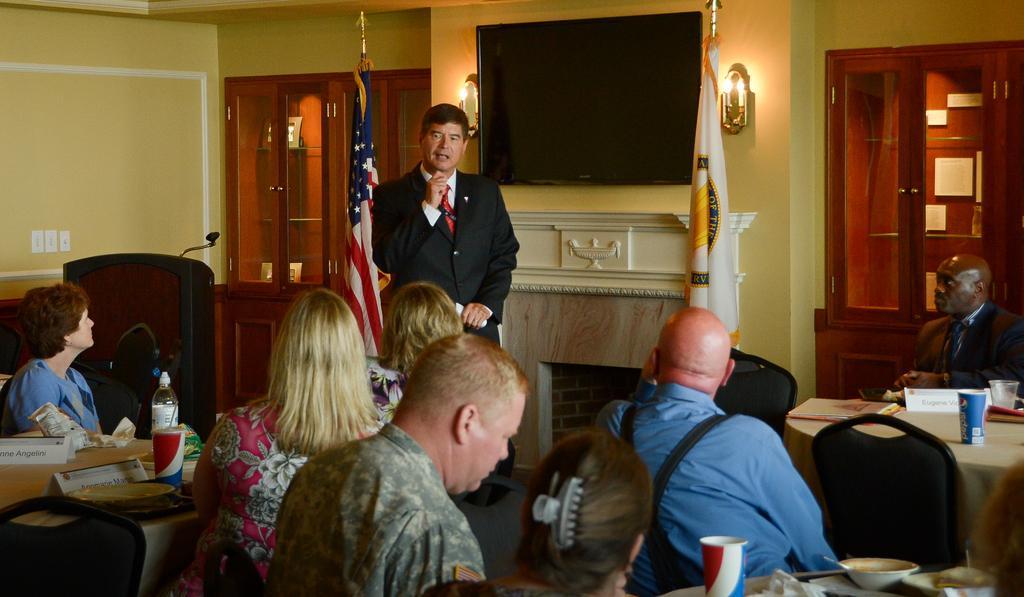How would you summarize this image in a sentence or two? some persons are sitting on the charts in front of them there is a table on the table we have some Cup glasses papers boards opposite to them one person is standing and his speaking back of the person there is a television and two flags one is at right side and one is at left side 